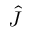<formula> <loc_0><loc_0><loc_500><loc_500>\hat { J }</formula> 